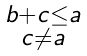Convert formula to latex. <formula><loc_0><loc_0><loc_500><loc_500>\begin{smallmatrix} b + c \leq a \\ c \ne a \end{smallmatrix}</formula> 